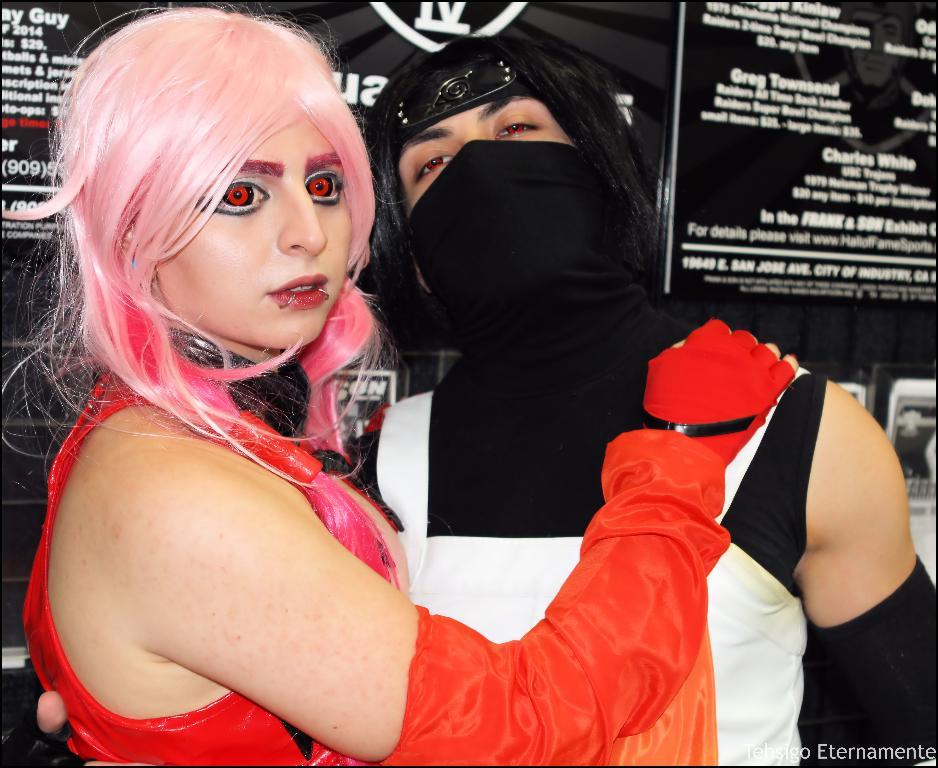<image>
Write a terse but informative summary of the picture. A girl with scary red eyes stands in front of a black sign with Charles White and Gregeg Townsend listed 